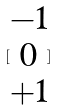<formula> <loc_0><loc_0><loc_500><loc_500>[ \begin{matrix} - 1 \\ 0 \\ + 1 \end{matrix} ]</formula> 